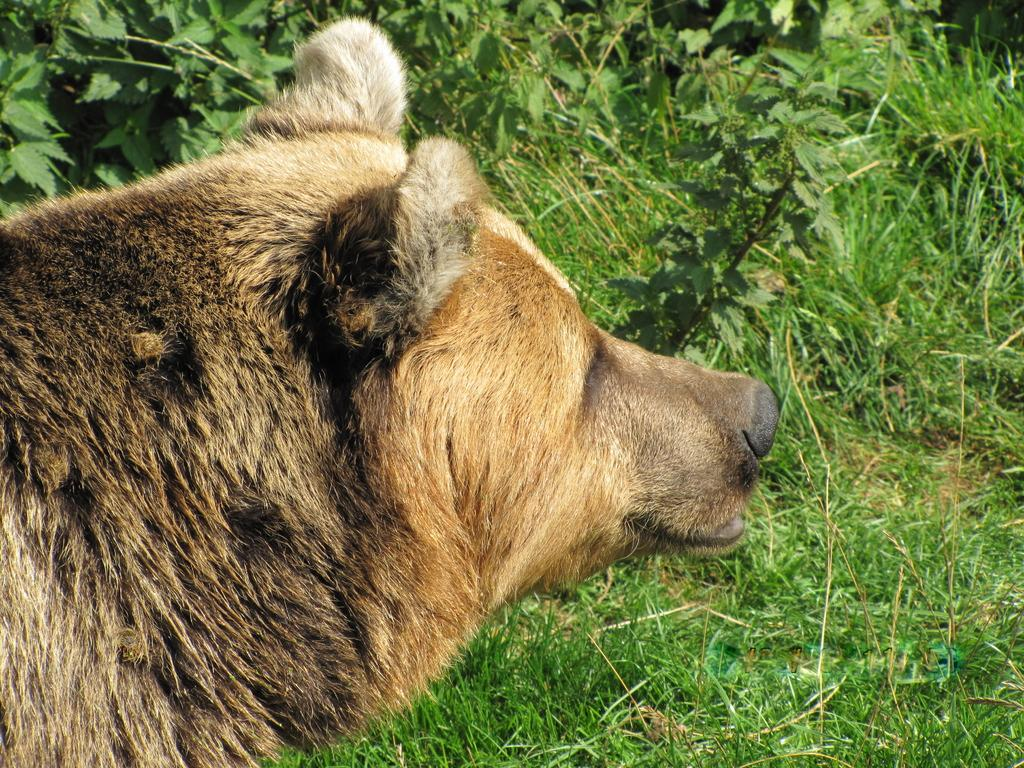What type of animal is present in the image? There is an animal in the image, but its specific type cannot be determined from the provided facts. What can be seen in the background of the image? There are plants and grass visible in the background of the image. What type of disgusting crayon can be seen in the image? There is no crayon present in the image, and therefore no such object can be observed. 